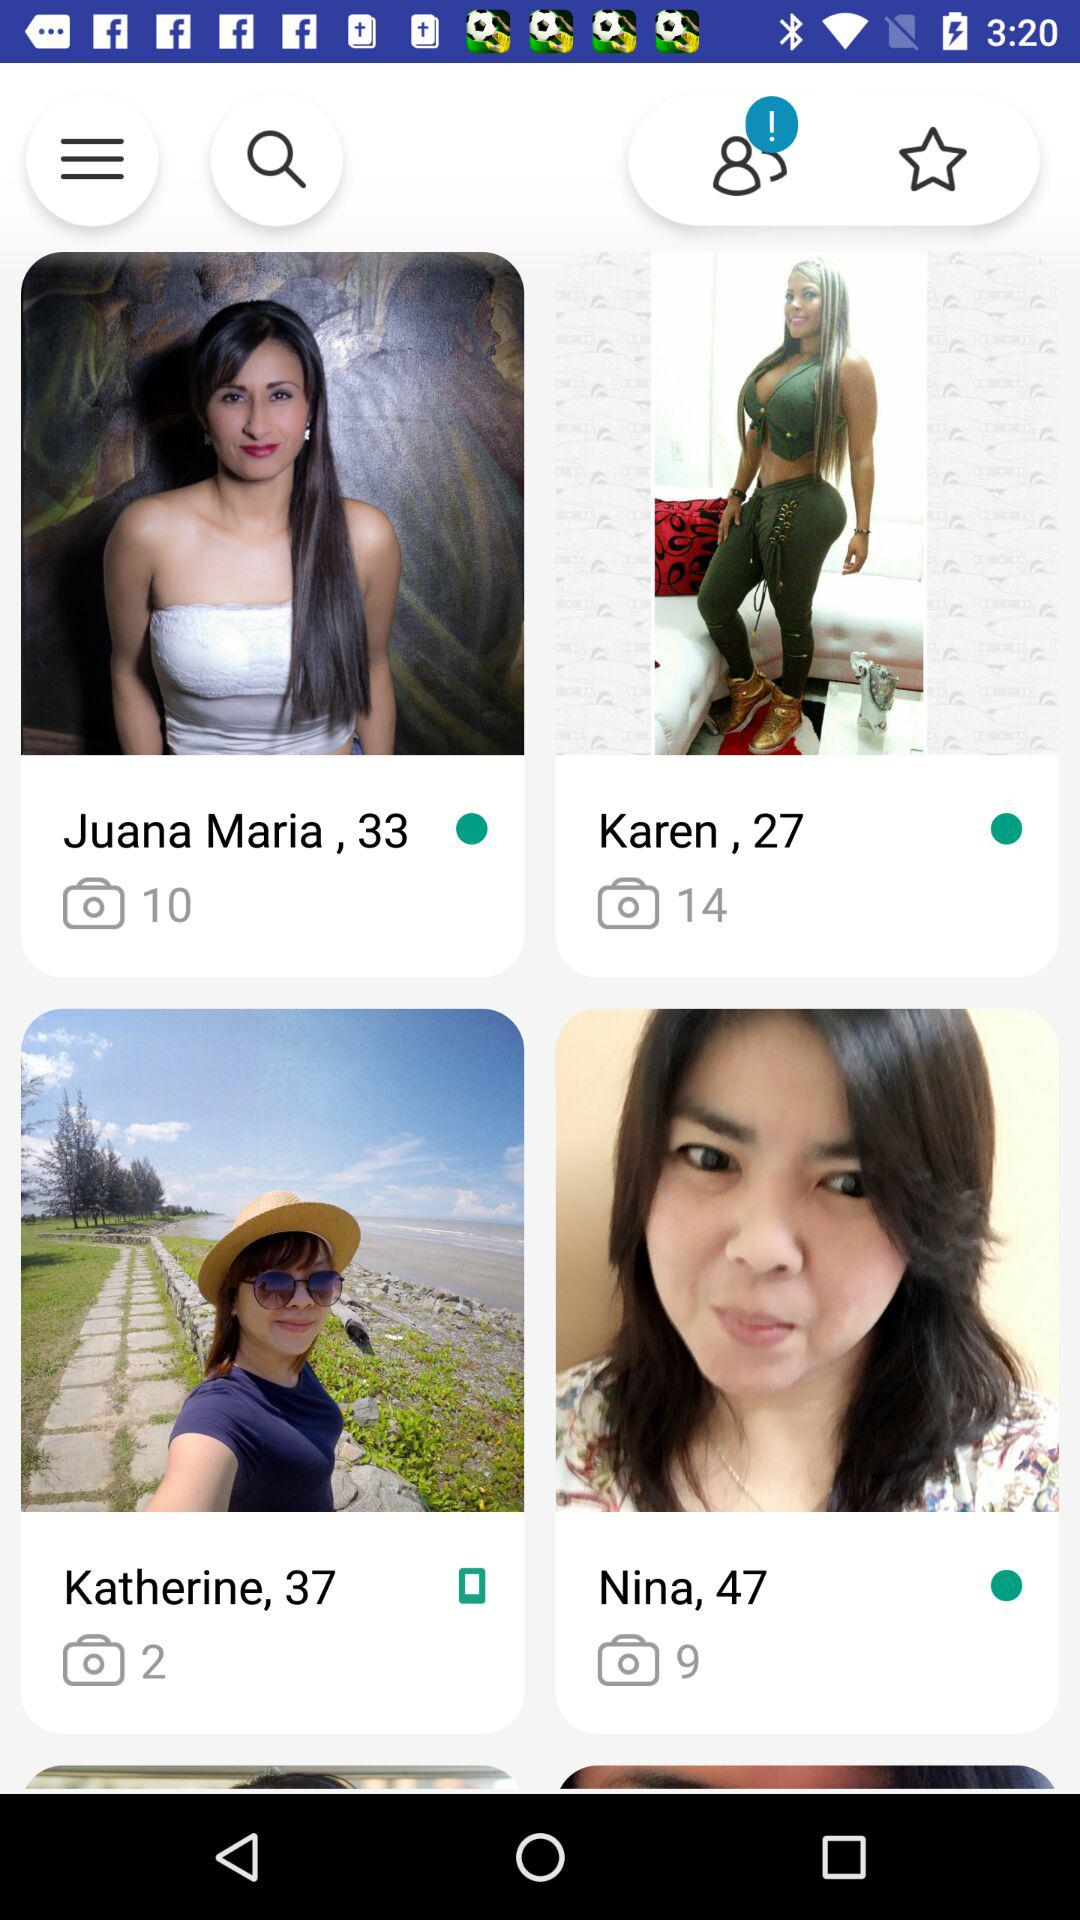What is the age of Karen? The age of Karen is 27. 